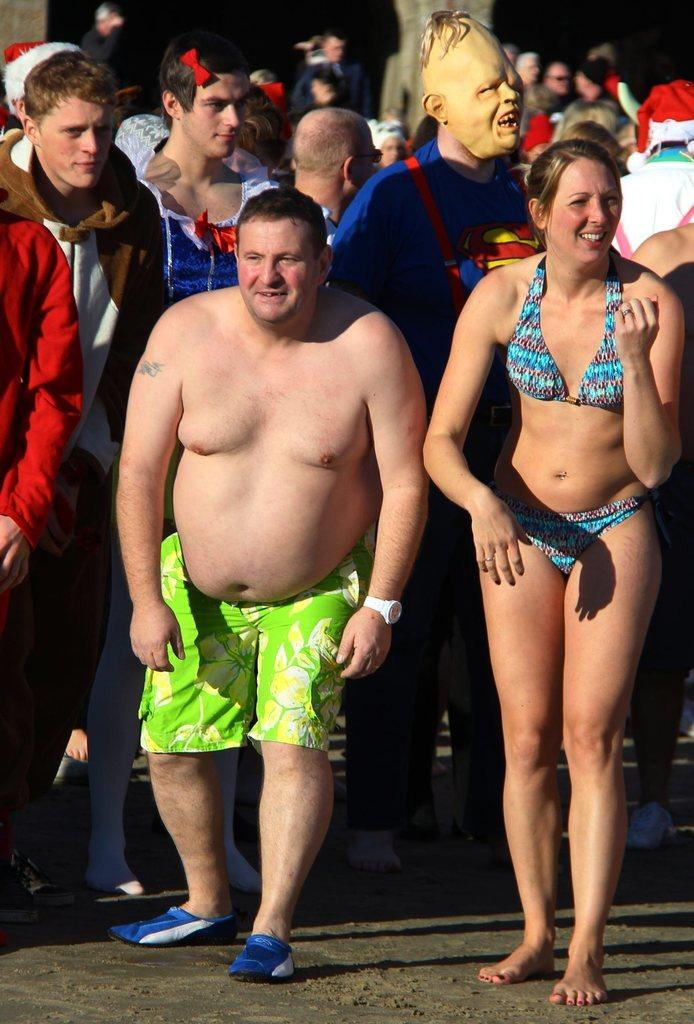How many people are in the image? The number of people in the image cannot be determined from the provided facts. What are the people doing in the image? The provided facts do not specify what the people are doing in the image. What is the surface beneath the people in the image? The people are standing on the ground in the image. What type of pen is being used by the person in the image? There is no pen present in the image, as the provided facts only mention that there are people standing on the ground. 